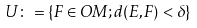<formula> <loc_0><loc_0><loc_500><loc_500>\ U \colon = \{ F \in O M ; d ( E , F ) < \delta \}</formula> 